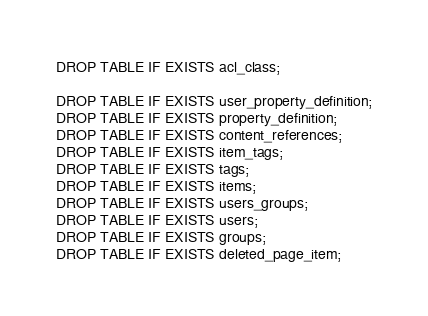<code> <loc_0><loc_0><loc_500><loc_500><_SQL_>DROP TABLE IF EXISTS acl_class;

DROP TABLE IF EXISTS user_property_definition;
DROP TABLE IF EXISTS property_definition;
DROP TABLE IF EXISTS content_references;
DROP TABLE IF EXISTS item_tags;
DROP TABLE IF EXISTS tags;
DROP TABLE IF EXISTS items;
DROP TABLE IF EXISTS users_groups;
DROP TABLE IF EXISTS users;
DROP TABLE IF EXISTS groups;
DROP TABLE IF EXISTS deleted_page_item;</code> 